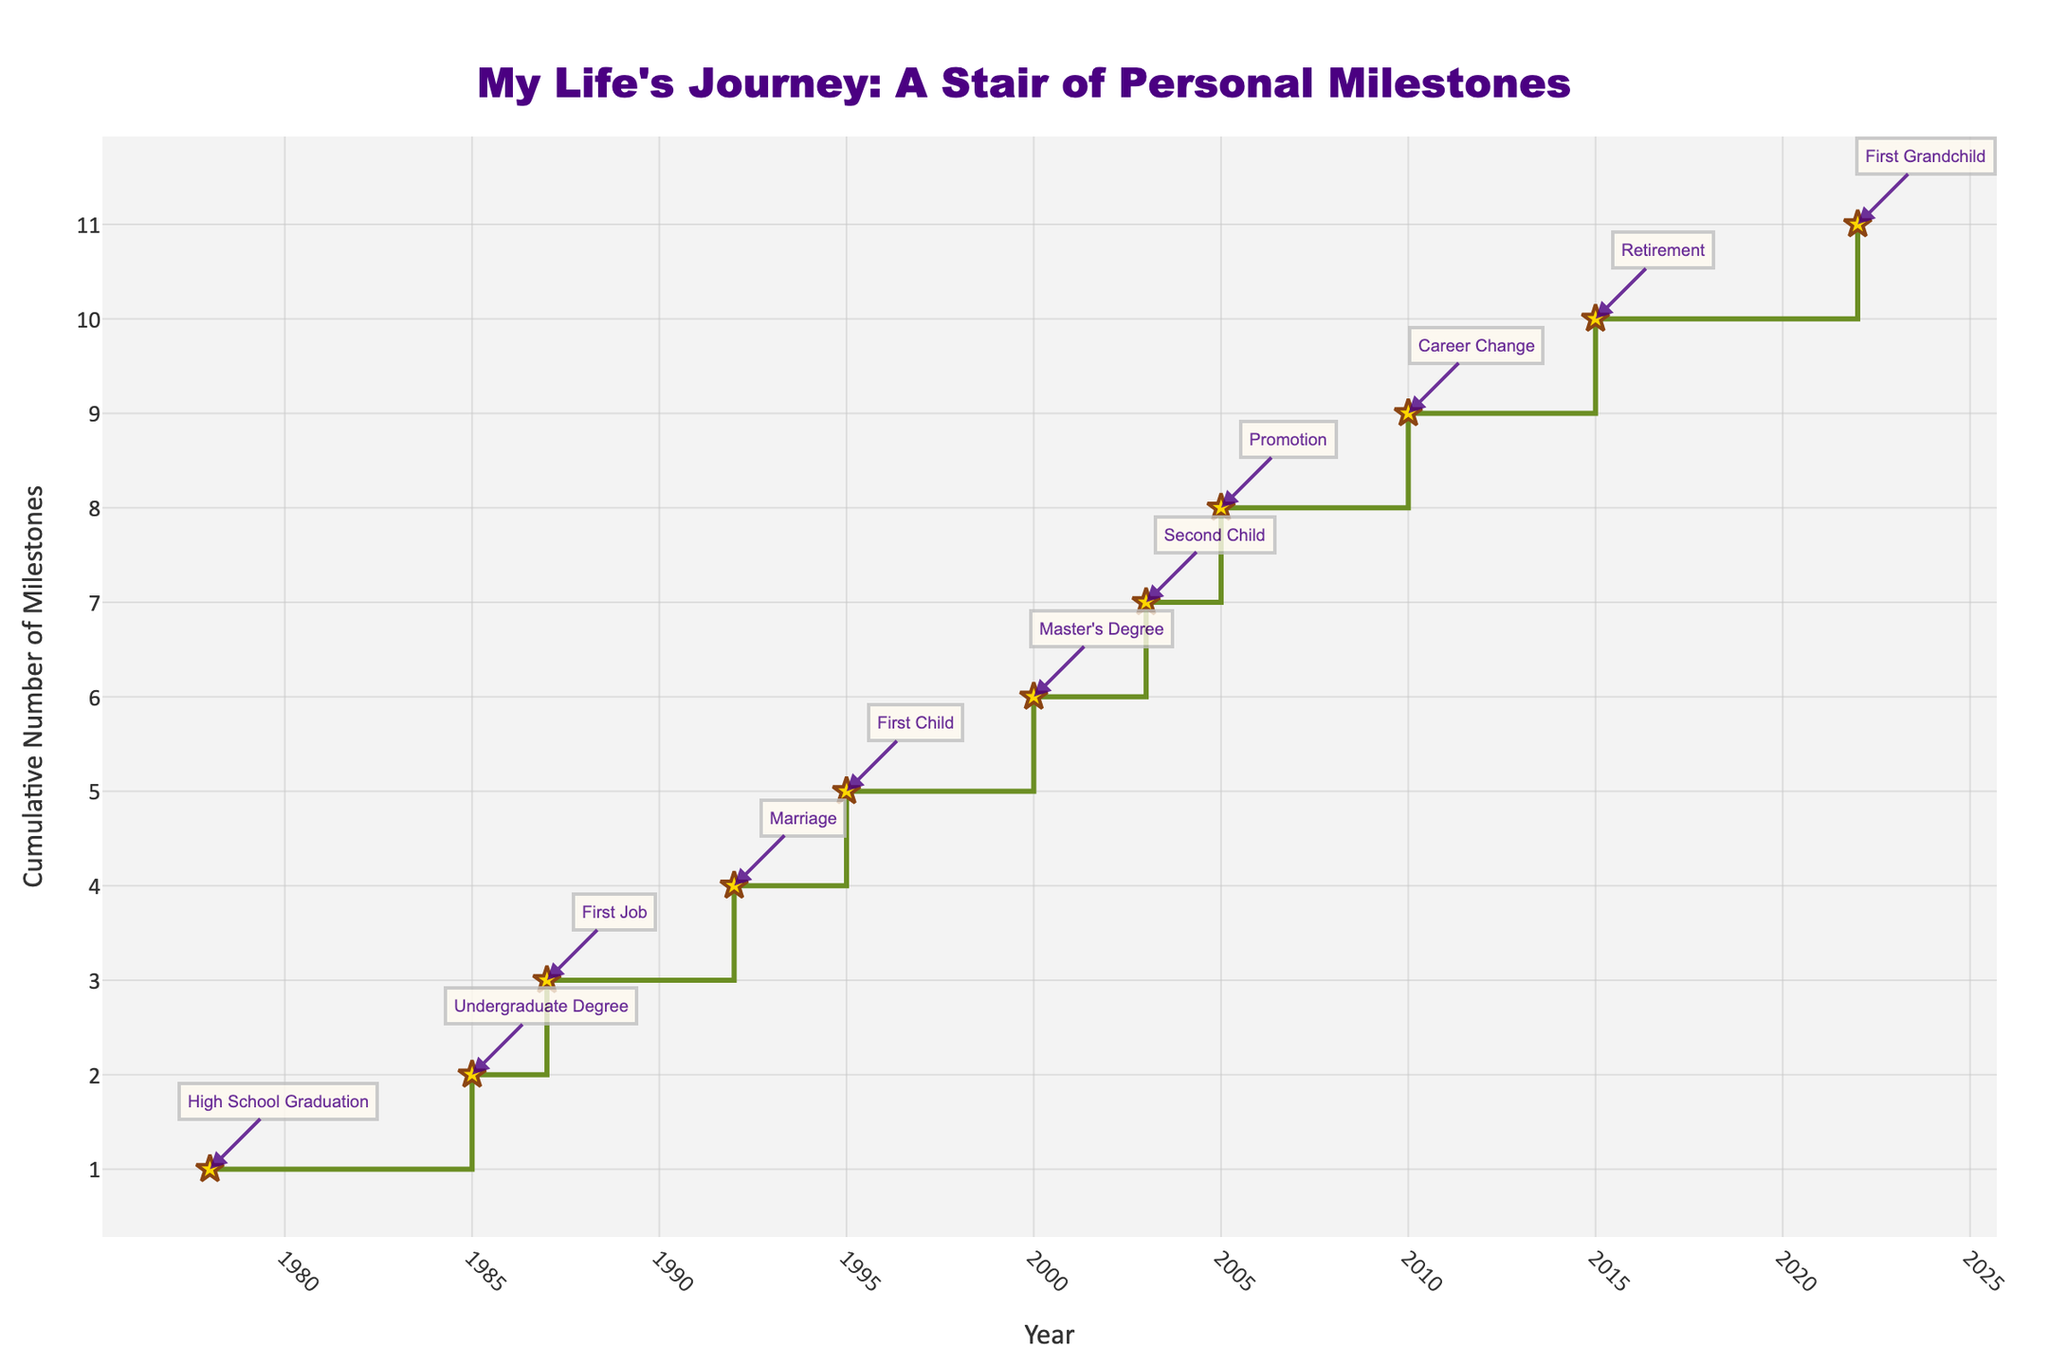What is the title of this stair plot? The title is usually positioned prominently at the top of the plot and is easily readable. In this case, it reads "My Life's Journey: A Stair of Personal Milestones".
Answer: "My Life's Journey: A Stair of Personal Milestones" How many personal milestones are shown in the plot? Counting the cumulative number of milestones along the Y-axis, one can see it goes up to 11. Thus, there are 11 events.
Answer: 11 Which year had the most recent personal milestone? By examining the markers and the annotations on the plot, the most recent milestone is positioned at the far-right end of the X-axis, which corresponds to the year 2022 (First Grandchild).
Answer: 2022 What was the milestone associated with the first marker on the plot? The first marker on the plot is associated with the earliest year on the X-axis, which is 1978, and the annotation indicates it was "High School Graduation".
Answer: High School Graduation What milestone occurred right after the birth of the first child? To find this, one can look at the annotations and markers after the one for "First Child" in 1995. The next milestone, in the sequence, is "Master's Degree" in 2000.
Answer: Master's Degree How many milestones occurred before the year 2000? Examining the markers and annotations before the year 2000 on the X-axis, the milestones before 2000 are five: High School Graduation, Undergraduate Degree, First Job, Marriage, and First Child.
Answer: 5 What is the gap in years between the first job and the promotion to Senior Engineer? The first job started in 1987 and the promotion to Senior Engineer occurred in 2005. The difference in years between these events is 2005 - 1987 = 18 years.
Answer: 18 years Did any two milestones occur in the same year? By looking at the annotations and markers, we see that no two milestones are annotated with the same year; each milestone occurs in a distinct year.
Answer: No Which milestone has the annotation with the description mentioning "Durban"? Checking the annotations, there are two milestones mentioning "Durban": "Career Change" in 2010 and "First Grandchild" in 2022.
Answer: Career Change and First Grandchild How many years after retirement was the first grandchild born? Retirement occurred in 2015 and the first grandchild was born in 2022. The difference in years between these events is 2022 - 2015 = 7 years.
Answer: 7 years 